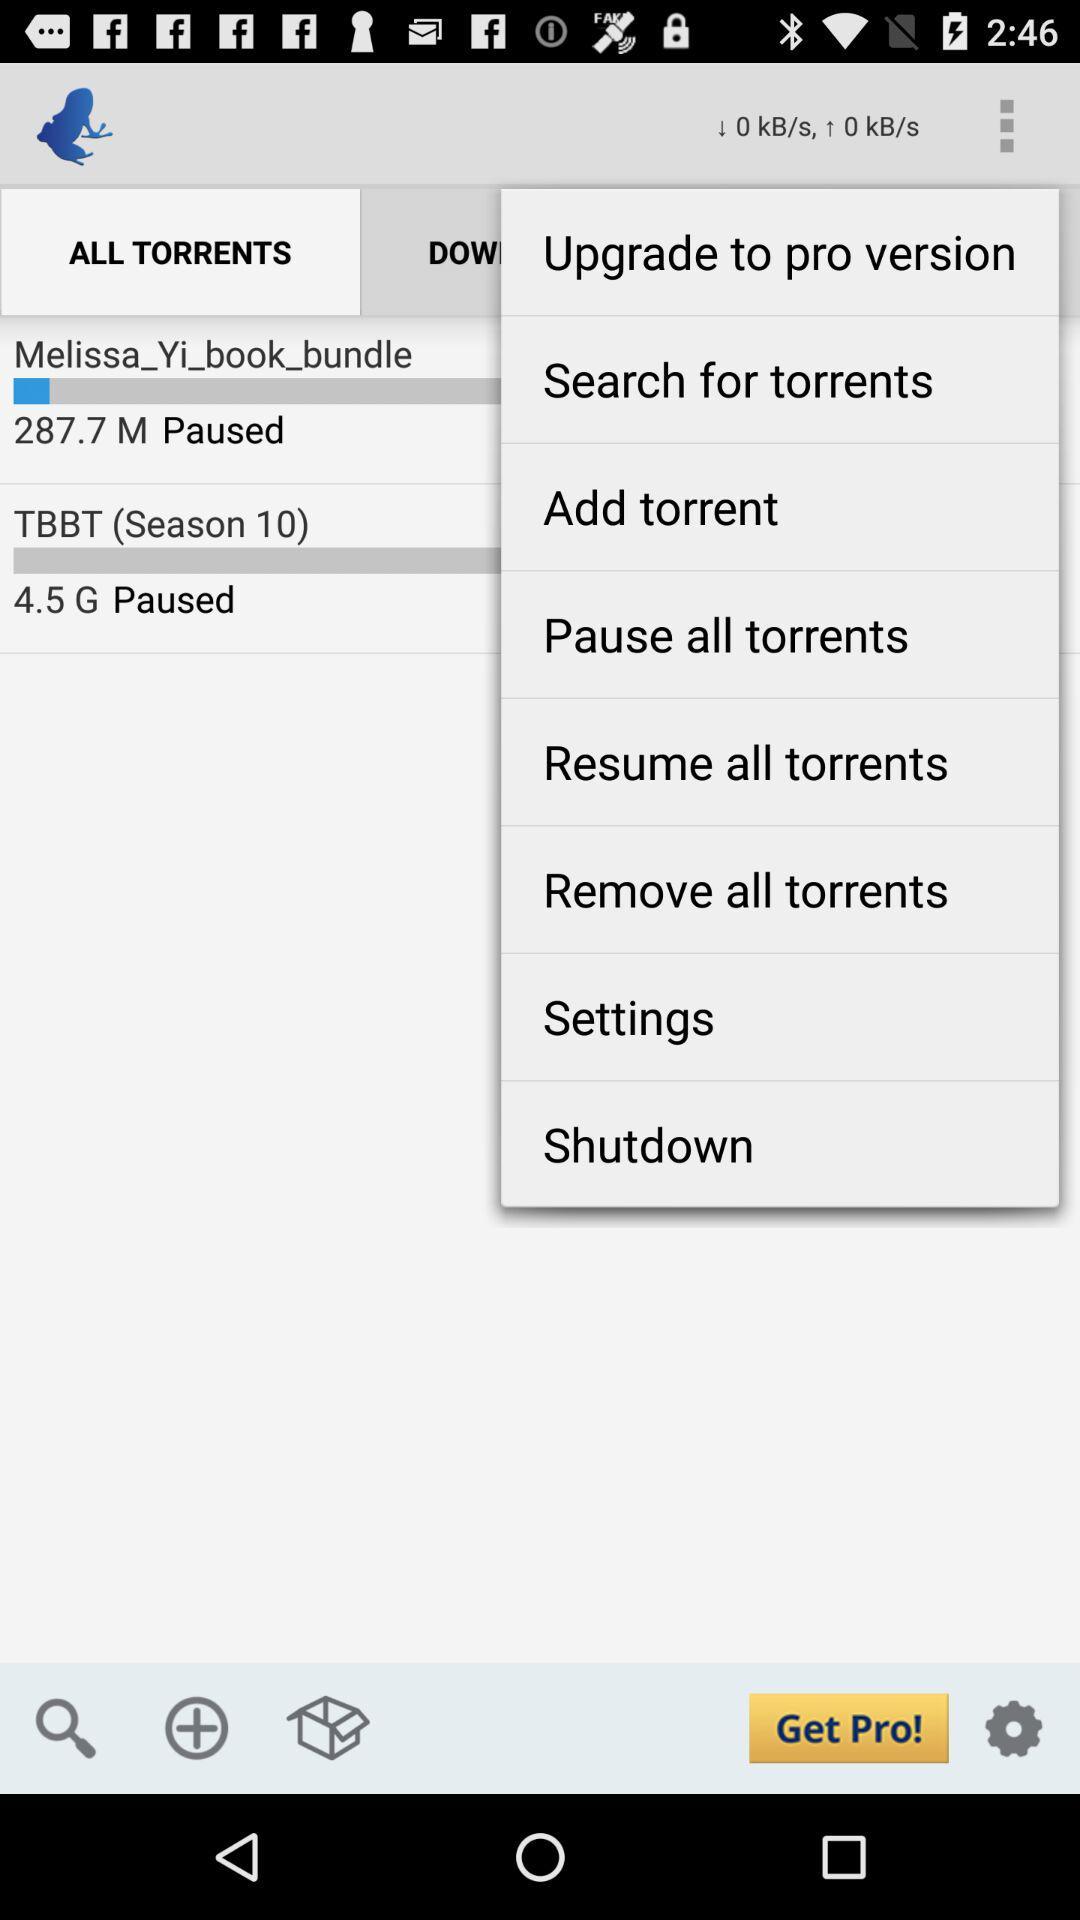Is the pro version paid or free?
When the provided information is insufficient, respond with <no answer>. <no answer> 